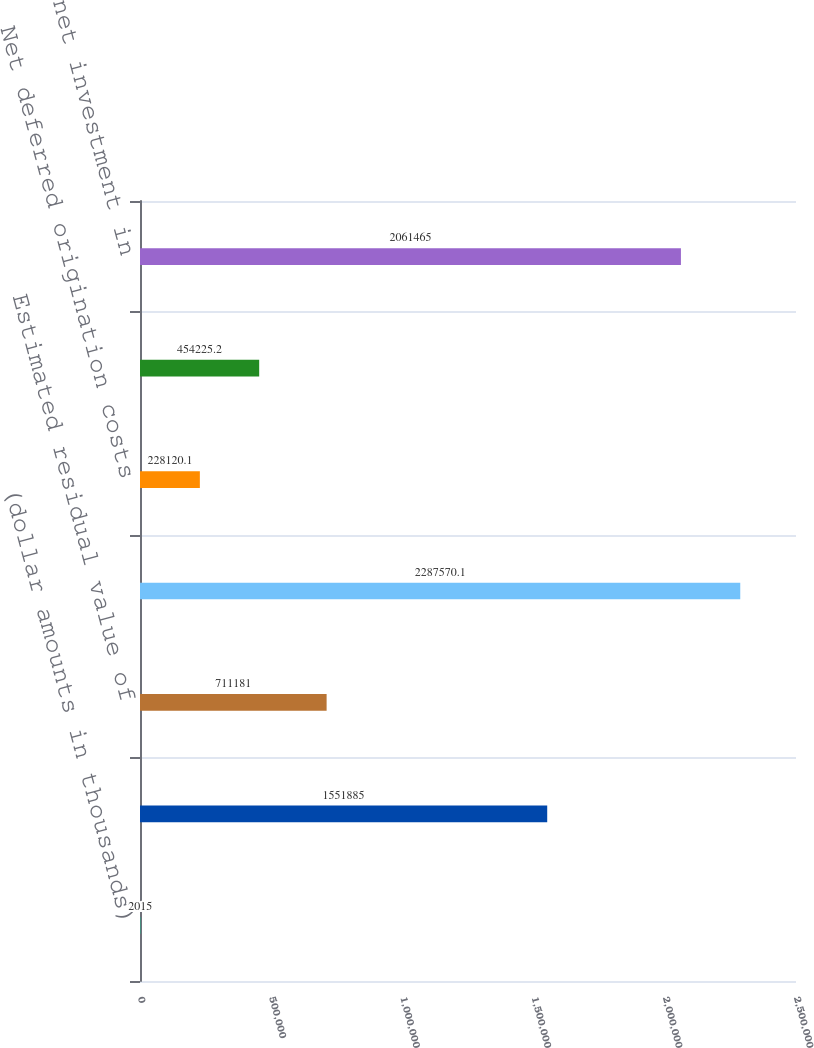Convert chart. <chart><loc_0><loc_0><loc_500><loc_500><bar_chart><fcel>(dollar amounts in thousands)<fcel>Lease payments receivable<fcel>Estimated residual value of<fcel>Gross investment in commercial<fcel>Net deferred origination costs<fcel>Deferred fees<fcel>Total net investment in<nl><fcel>2015<fcel>1.55188e+06<fcel>711181<fcel>2.28757e+06<fcel>228120<fcel>454225<fcel>2.06146e+06<nl></chart> 